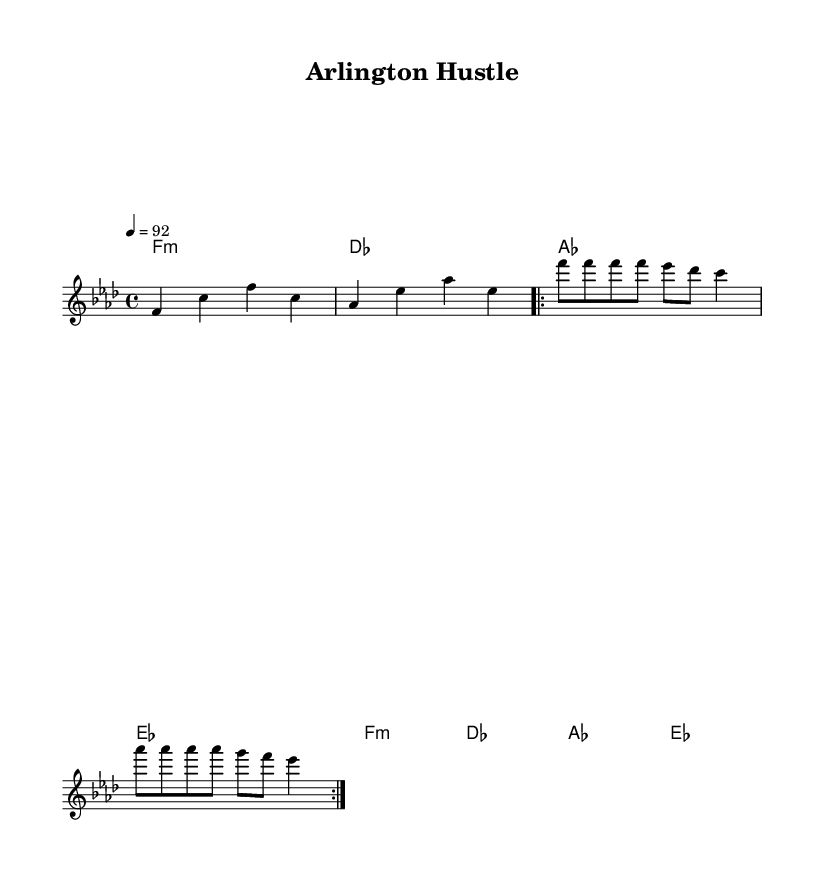What is the key signature of this music? The key signature is indicated at the beginning of the score. In this case, it shows that the music is in F minor, which has four flats.
Answer: F minor What is the time signature of this music? The time signature is located at the beginning of the score, showing that the music has a structure of 4 beats per measure. This is indicated as 4/4.
Answer: 4/4 What is the tempo marking for this music? The tempo marking is noted in beats per minute, which is set to 92. This indicates the speed at which the music should be played.
Answer: 92 How many times is the chorus repeated in the sheet music? The repeat indication is marked in the chorus section, specifying that it is to be repeated two times.
Answer: 2 What genre does this music represent? The lyrics and style of the music, including themes of hustle and deals in real estate, indicate that it belongs to the genre of rap.
Answer: Rap What is the main theme of the lyrics in the verse? The lyrics detail the real estate market situations, suggesting a focus on the process of selling homes and the nature of the business in Arlington.
Answer: Real estate hustle 